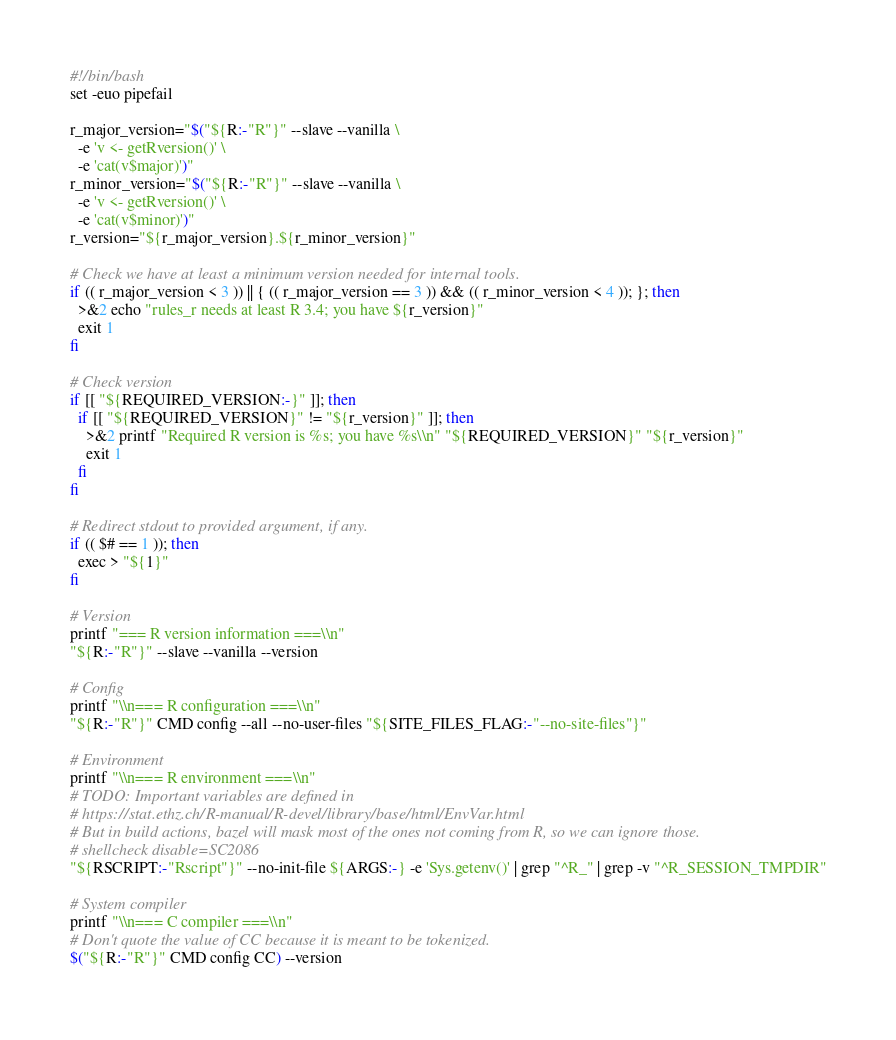<code> <loc_0><loc_0><loc_500><loc_500><_Bash_>#!/bin/bash
set -euo pipefail

r_major_version="$("${R:-"R"}" --slave --vanilla \
  -e 'v <- getRversion()' \
  -e 'cat(v$major)')"
r_minor_version="$("${R:-"R"}" --slave --vanilla \
  -e 'v <- getRversion()' \
  -e 'cat(v$minor)')"
r_version="${r_major_version}.${r_minor_version}"

# Check we have at least a minimum version needed for internal tools.
if (( r_major_version < 3 )) || { (( r_major_version == 3 )) && (( r_minor_version < 4 )); }; then
  >&2 echo "rules_r needs at least R 3.4; you have ${r_version}"
  exit 1
fi

# Check version
if [[ "${REQUIRED_VERSION:-}" ]]; then
  if [[ "${REQUIRED_VERSION}" != "${r_version}" ]]; then
    >&2 printf "Required R version is %s; you have %s\\n" "${REQUIRED_VERSION}" "${r_version}"
    exit 1
  fi
fi

# Redirect stdout to provided argument, if any.
if (( $# == 1 )); then
  exec > "${1}"
fi

# Version
printf "=== R version information ===\\n"
"${R:-"R"}" --slave --vanilla --version

# Config
printf "\\n=== R configuration ===\\n"
"${R:-"R"}" CMD config --all --no-user-files "${SITE_FILES_FLAG:-"--no-site-files"}"

# Environment
printf "\\n=== R environment ===\\n"
# TODO: Important variables are defined in
# https://stat.ethz.ch/R-manual/R-devel/library/base/html/EnvVar.html
# But in build actions, bazel will mask most of the ones not coming from R, so we can ignore those.
# shellcheck disable=SC2086
"${RSCRIPT:-"Rscript"}" --no-init-file ${ARGS:-} -e 'Sys.getenv()' | grep "^R_" | grep -v "^R_SESSION_TMPDIR"

# System compiler
printf "\\n=== C compiler ===\\n"
# Don't quote the value of CC because it is meant to be tokenized.
$("${R:-"R"}" CMD config CC) --version
</code> 